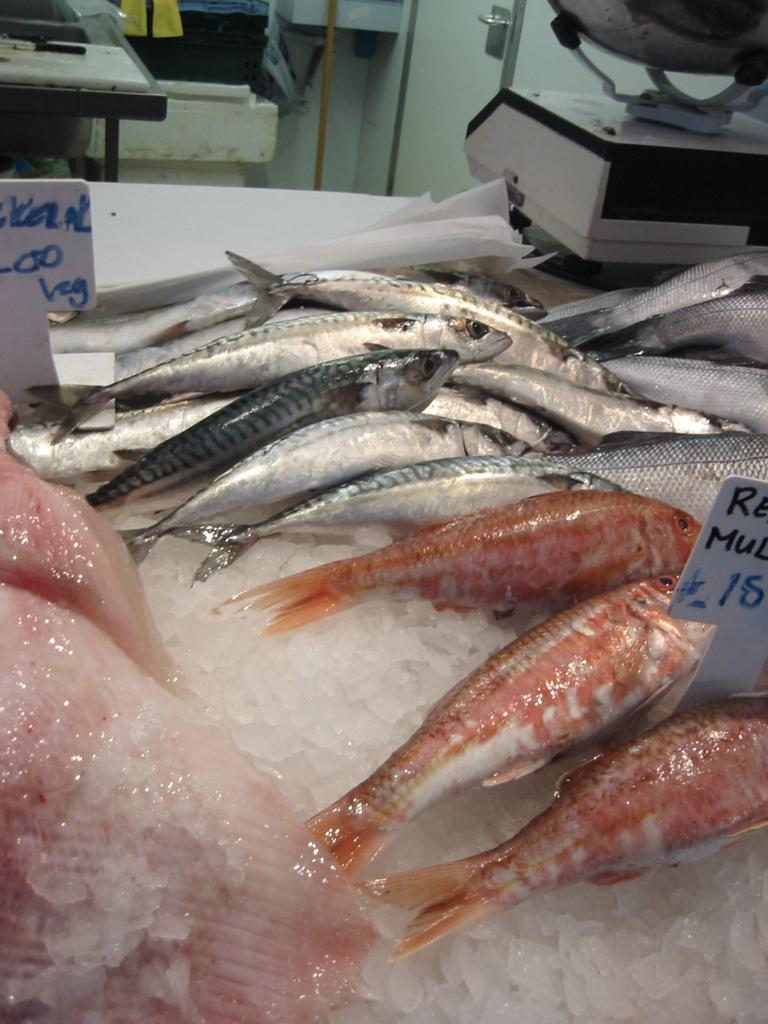What is present in the ice in the image? There are fishes in the ice. What can be found on the small boards in the image? There are two small boards with written text in the image. What is located on the table in the image? There are equipment on a table in the image. What type of object is present in the image that is used for transporting fluids? There is a pipe in the image. What feature in the image might allow access to another room or area? There is a door in the image. What type of punishment is being administered to the fishes in the image? There is no punishment being administered to the fishes in the image; they are simply present in the ice. How does the comb play a role in the image? There is no comb present in the image. 